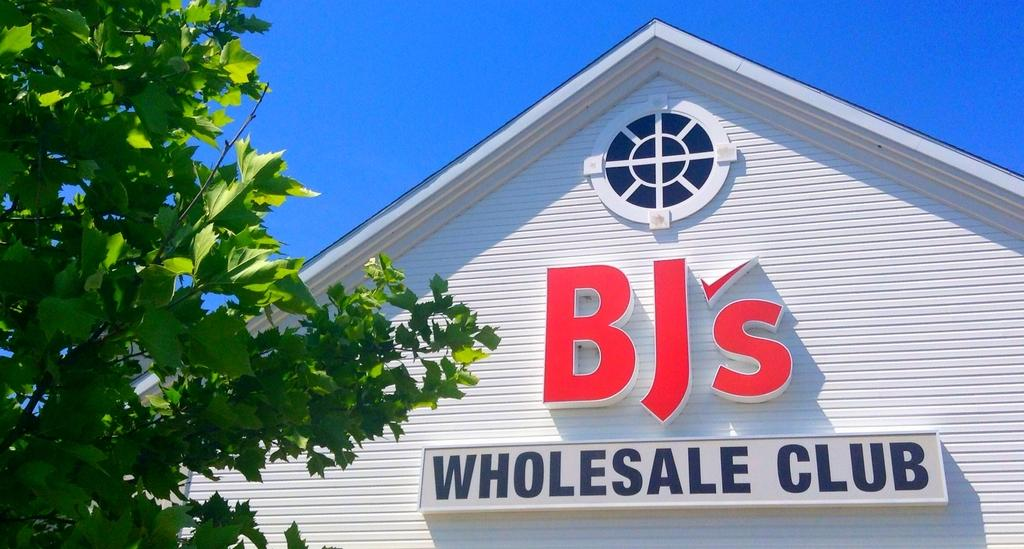<image>
Relay a brief, clear account of the picture shown. A building with siding that says Bj's Wholesale club. 